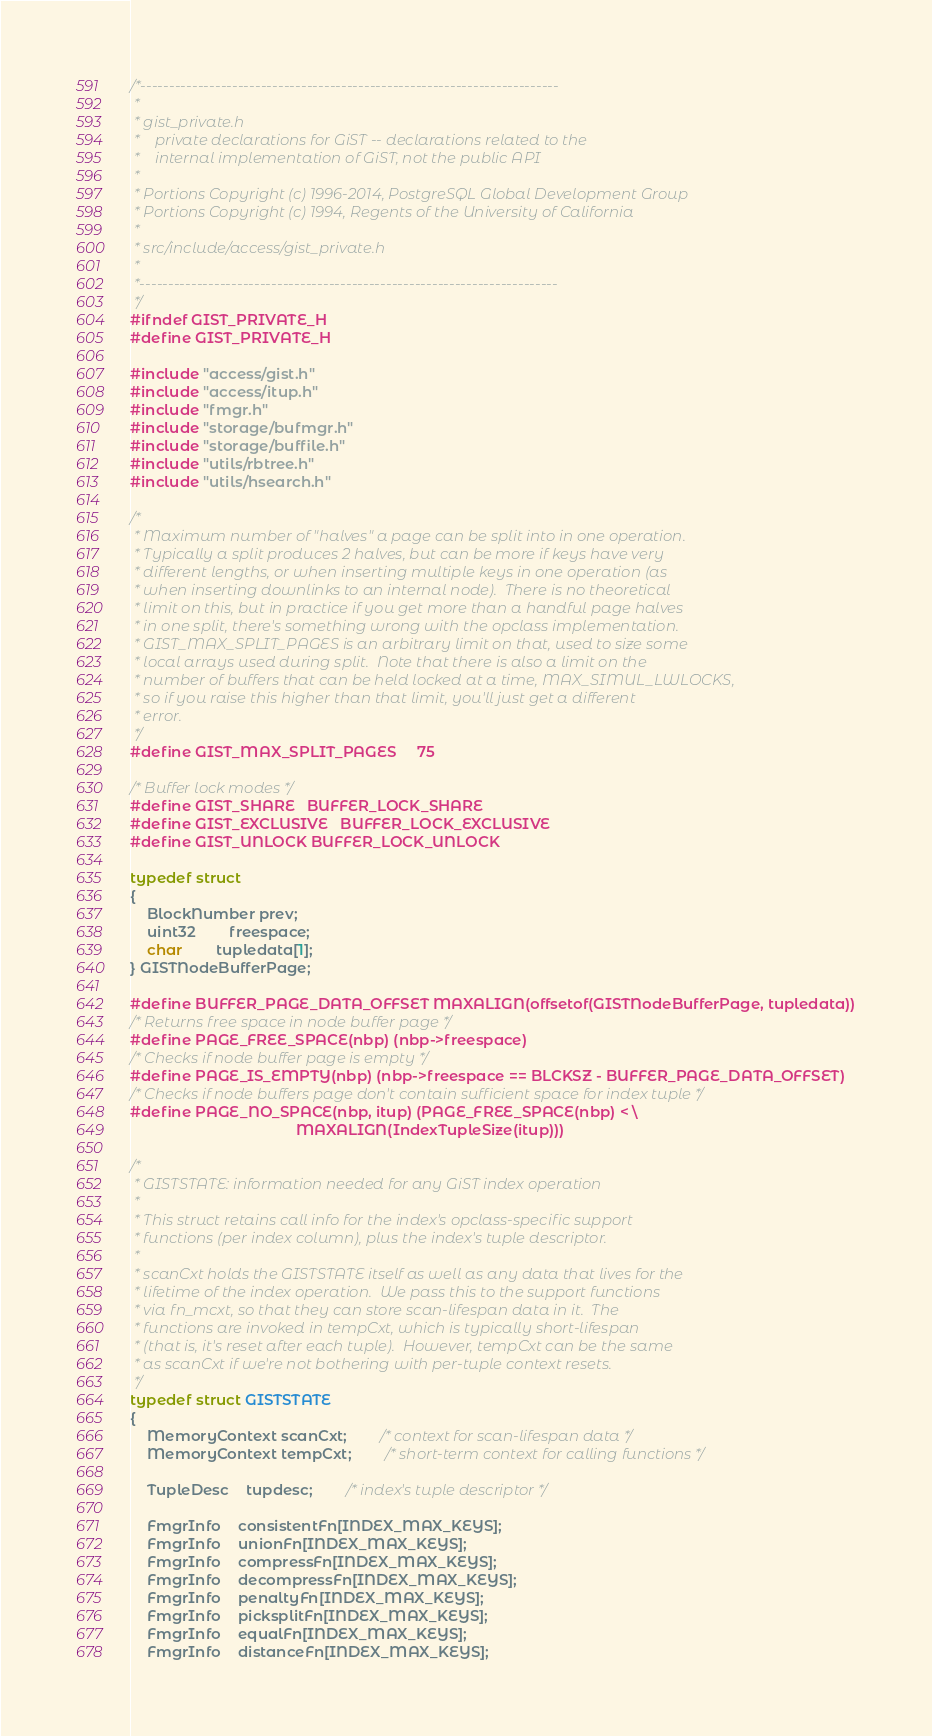Convert code to text. <code><loc_0><loc_0><loc_500><loc_500><_C_>/*-------------------------------------------------------------------------
 *
 * gist_private.h
 *	  private declarations for GiST -- declarations related to the
 *	  internal implementation of GiST, not the public API
 *
 * Portions Copyright (c) 1996-2014, PostgreSQL Global Development Group
 * Portions Copyright (c) 1994, Regents of the University of California
 *
 * src/include/access/gist_private.h
 *
 *-------------------------------------------------------------------------
 */
#ifndef GIST_PRIVATE_H
#define GIST_PRIVATE_H

#include "access/gist.h"
#include "access/itup.h"
#include "fmgr.h"
#include "storage/bufmgr.h"
#include "storage/buffile.h"
#include "utils/rbtree.h"
#include "utils/hsearch.h"

/*
 * Maximum number of "halves" a page can be split into in one operation.
 * Typically a split produces 2 halves, but can be more if keys have very
 * different lengths, or when inserting multiple keys in one operation (as
 * when inserting downlinks to an internal node).  There is no theoretical
 * limit on this, but in practice if you get more than a handful page halves
 * in one split, there's something wrong with the opclass implementation.
 * GIST_MAX_SPLIT_PAGES is an arbitrary limit on that, used to size some
 * local arrays used during split.  Note that there is also a limit on the
 * number of buffers that can be held locked at a time, MAX_SIMUL_LWLOCKS,
 * so if you raise this higher than that limit, you'll just get a different
 * error.
 */
#define GIST_MAX_SPLIT_PAGES		75

/* Buffer lock modes */
#define GIST_SHARE	BUFFER_LOCK_SHARE
#define GIST_EXCLUSIVE	BUFFER_LOCK_EXCLUSIVE
#define GIST_UNLOCK BUFFER_LOCK_UNLOCK

typedef struct
{
	BlockNumber prev;
	uint32		freespace;
	char		tupledata[1];
} GISTNodeBufferPage;

#define BUFFER_PAGE_DATA_OFFSET MAXALIGN(offsetof(GISTNodeBufferPage, tupledata))
/* Returns free space in node buffer page */
#define PAGE_FREE_SPACE(nbp) (nbp->freespace)
/* Checks if node buffer page is empty */
#define PAGE_IS_EMPTY(nbp) (nbp->freespace == BLCKSZ - BUFFER_PAGE_DATA_OFFSET)
/* Checks if node buffers page don't contain sufficient space for index tuple */
#define PAGE_NO_SPACE(nbp, itup) (PAGE_FREE_SPACE(nbp) < \
										MAXALIGN(IndexTupleSize(itup)))

/*
 * GISTSTATE: information needed for any GiST index operation
 *
 * This struct retains call info for the index's opclass-specific support
 * functions (per index column), plus the index's tuple descriptor.
 *
 * scanCxt holds the GISTSTATE itself as well as any data that lives for the
 * lifetime of the index operation.  We pass this to the support functions
 * via fn_mcxt, so that they can store scan-lifespan data in it.  The
 * functions are invoked in tempCxt, which is typically short-lifespan
 * (that is, it's reset after each tuple).  However, tempCxt can be the same
 * as scanCxt if we're not bothering with per-tuple context resets.
 */
typedef struct GISTSTATE
{
	MemoryContext scanCxt;		/* context for scan-lifespan data */
	MemoryContext tempCxt;		/* short-term context for calling functions */

	TupleDesc	tupdesc;		/* index's tuple descriptor */

	FmgrInfo	consistentFn[INDEX_MAX_KEYS];
	FmgrInfo	unionFn[INDEX_MAX_KEYS];
	FmgrInfo	compressFn[INDEX_MAX_KEYS];
	FmgrInfo	decompressFn[INDEX_MAX_KEYS];
	FmgrInfo	penaltyFn[INDEX_MAX_KEYS];
	FmgrInfo	picksplitFn[INDEX_MAX_KEYS];
	FmgrInfo	equalFn[INDEX_MAX_KEYS];
	FmgrInfo	distanceFn[INDEX_MAX_KEYS];
</code> 